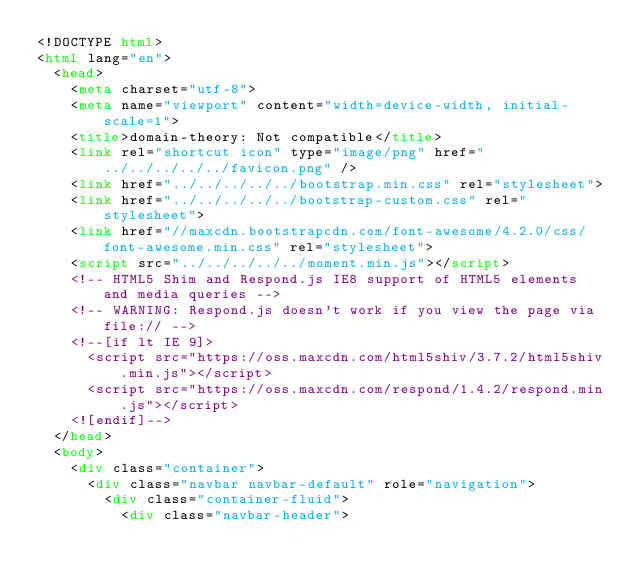<code> <loc_0><loc_0><loc_500><loc_500><_HTML_><!DOCTYPE html>
<html lang="en">
  <head>
    <meta charset="utf-8">
    <meta name="viewport" content="width=device-width, initial-scale=1">
    <title>domain-theory: Not compatible</title>
    <link rel="shortcut icon" type="image/png" href="../../../../../favicon.png" />
    <link href="../../../../../bootstrap.min.css" rel="stylesheet">
    <link href="../../../../../bootstrap-custom.css" rel="stylesheet">
    <link href="//maxcdn.bootstrapcdn.com/font-awesome/4.2.0/css/font-awesome.min.css" rel="stylesheet">
    <script src="../../../../../moment.min.js"></script>
    <!-- HTML5 Shim and Respond.js IE8 support of HTML5 elements and media queries -->
    <!-- WARNING: Respond.js doesn't work if you view the page via file:// -->
    <!--[if lt IE 9]>
      <script src="https://oss.maxcdn.com/html5shiv/3.7.2/html5shiv.min.js"></script>
      <script src="https://oss.maxcdn.com/respond/1.4.2/respond.min.js"></script>
    <![endif]-->
  </head>
  <body>
    <div class="container">
      <div class="navbar navbar-default" role="navigation">
        <div class="container-fluid">
          <div class="navbar-header"></code> 